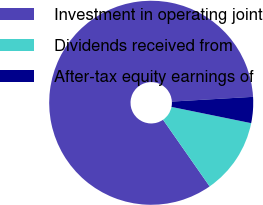<chart> <loc_0><loc_0><loc_500><loc_500><pie_chart><fcel>Investment in operating joint<fcel>Dividends received from<fcel>After-tax equity earnings of<nl><fcel>83.78%<fcel>12.09%<fcel>4.13%<nl></chart> 